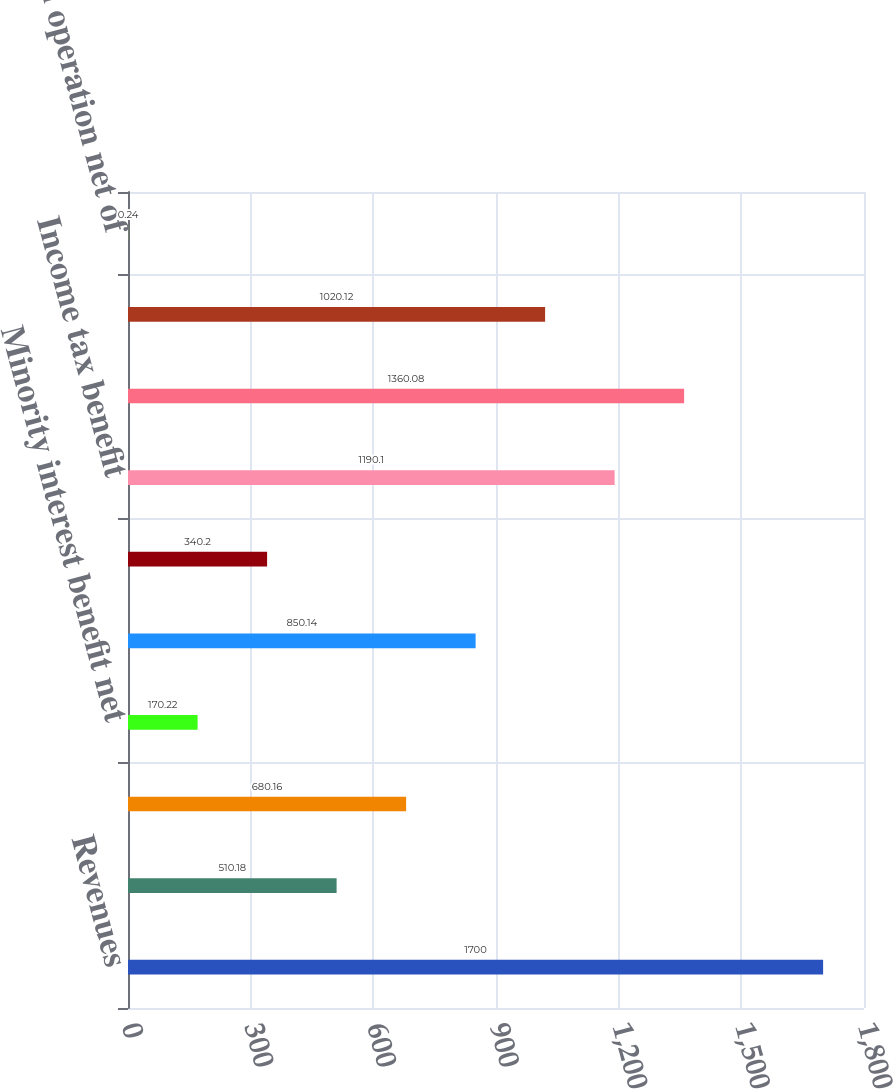Convert chart. <chart><loc_0><loc_0><loc_500><loc_500><bar_chart><fcel>Revenues<fcel>Loss from operation<fcel>Income tax expense<fcel>Minority interest benefit net<fcel>Loss from discontinued<fcel>Gain on sale of CHH<fcel>Income tax benefit<fcel>Gain on sale net of taxes and<fcel>Earnings from discontinued<fcel>Loss from operation net of<nl><fcel>1700<fcel>510.18<fcel>680.16<fcel>170.22<fcel>850.14<fcel>340.2<fcel>1190.1<fcel>1360.08<fcel>1020.12<fcel>0.24<nl></chart> 